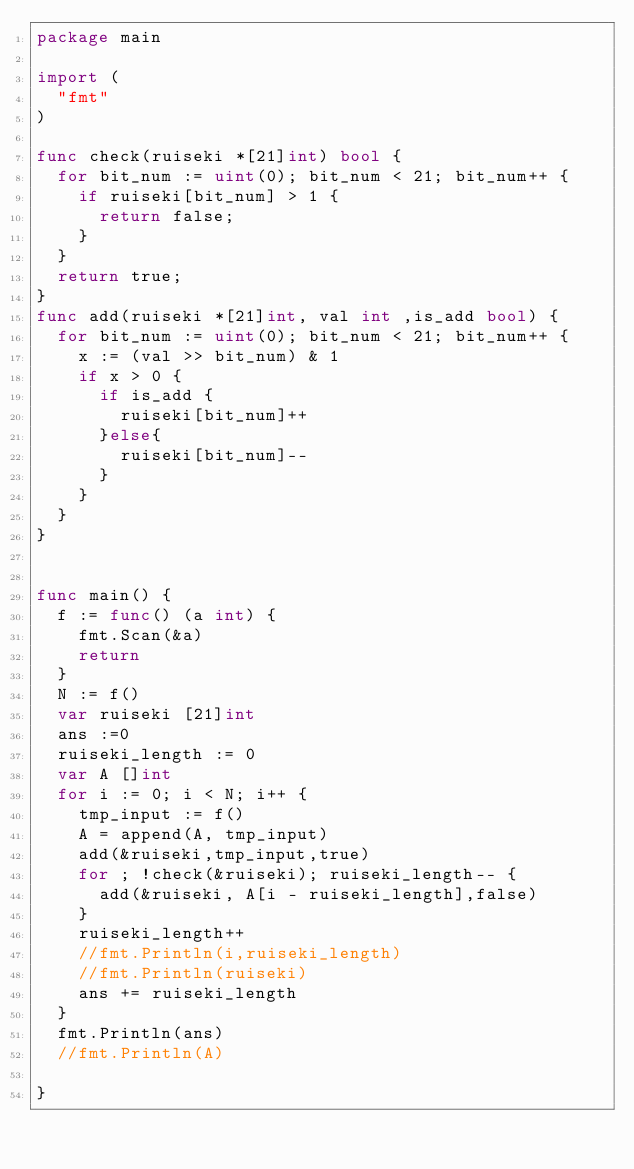<code> <loc_0><loc_0><loc_500><loc_500><_Go_>package main

import (
	"fmt"
)

func check(ruiseki *[21]int) bool {
	for bit_num := uint(0); bit_num < 21; bit_num++ {
		if ruiseki[bit_num] > 1 {
			return false;
		}
	}
	return true;
}
func add(ruiseki *[21]int, val int ,is_add bool) {
	for bit_num := uint(0); bit_num < 21; bit_num++ {
		x := (val >> bit_num) & 1
		if x > 0 {
			if is_add {
				ruiseki[bit_num]++
			}else{
				ruiseki[bit_num]--
			}
		}
	}
}


func main() {
	f := func() (a int) {
		fmt.Scan(&a)
		return
	}
	N := f()
	var ruiseki [21]int
	ans :=0
	ruiseki_length := 0
	var A []int
	for i := 0; i < N; i++ {
		tmp_input := f()
		A = append(A, tmp_input)
		add(&ruiseki,tmp_input,true)
		for ; !check(&ruiseki); ruiseki_length-- {
			add(&ruiseki, A[i - ruiseki_length],false)
		}
		ruiseki_length++
		//fmt.Println(i,ruiseki_length)
		//fmt.Println(ruiseki)
		ans += ruiseki_length
	}
	fmt.Println(ans)
	//fmt.Println(A)

}
</code> 